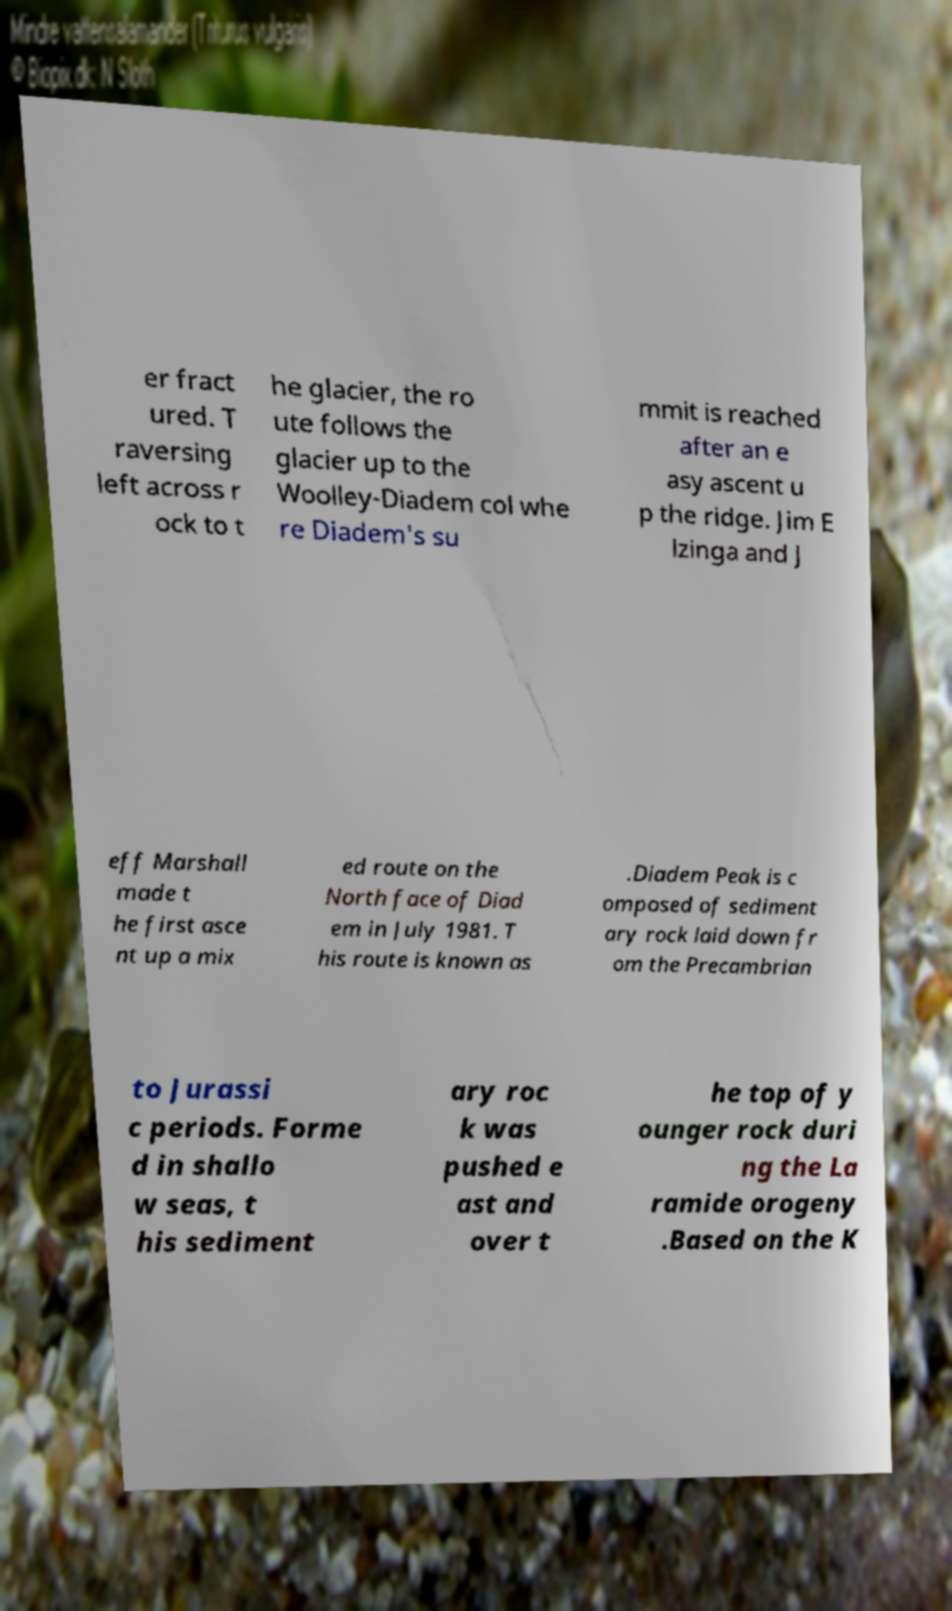Can you accurately transcribe the text from the provided image for me? er fract ured. T raversing left across r ock to t he glacier, the ro ute follows the glacier up to the Woolley-Diadem col whe re Diadem's su mmit is reached after an e asy ascent u p the ridge. Jim E lzinga and J eff Marshall made t he first asce nt up a mix ed route on the North face of Diad em in July 1981. T his route is known as .Diadem Peak is c omposed of sediment ary rock laid down fr om the Precambrian to Jurassi c periods. Forme d in shallo w seas, t his sediment ary roc k was pushed e ast and over t he top of y ounger rock duri ng the La ramide orogeny .Based on the K 